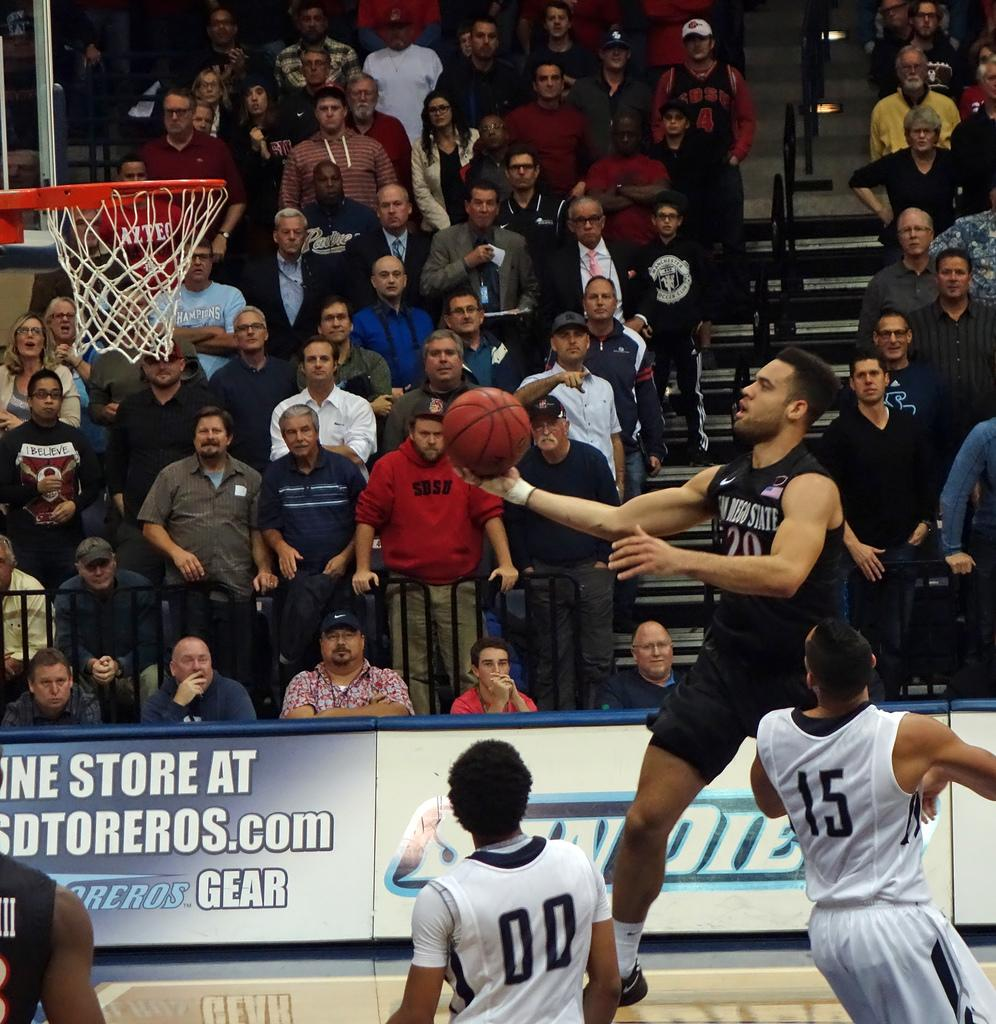<image>
Offer a succinct explanation of the picture presented. a player that has the number 15 on their back 